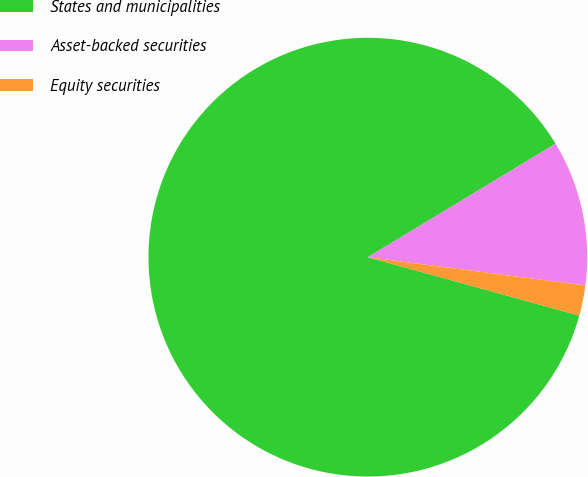<chart> <loc_0><loc_0><loc_500><loc_500><pie_chart><fcel>States and municipalities<fcel>Asset-backed securities<fcel>Equity securities<nl><fcel>87.05%<fcel>10.71%<fcel>2.23%<nl></chart> 